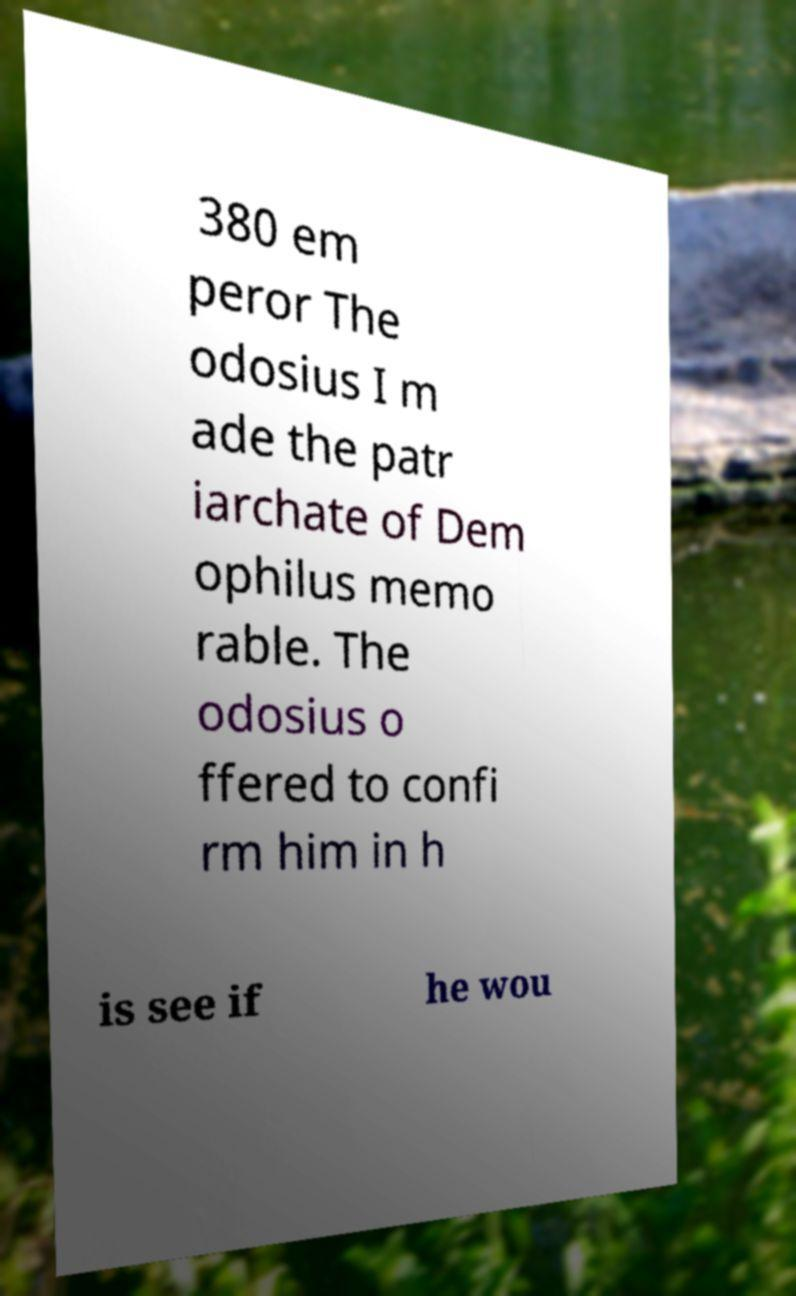I need the written content from this picture converted into text. Can you do that? 380 em peror The odosius I m ade the patr iarchate of Dem ophilus memo rable. The odosius o ffered to confi rm him in h is see if he wou 